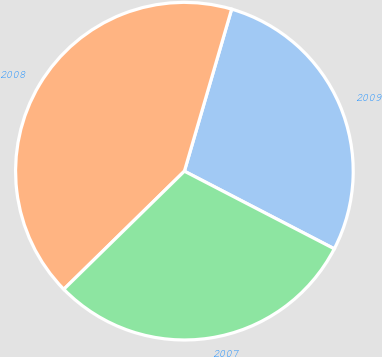Convert chart to OTSL. <chart><loc_0><loc_0><loc_500><loc_500><pie_chart><fcel>2009<fcel>2008<fcel>2007<nl><fcel>28.09%<fcel>41.85%<fcel>30.06%<nl></chart> 